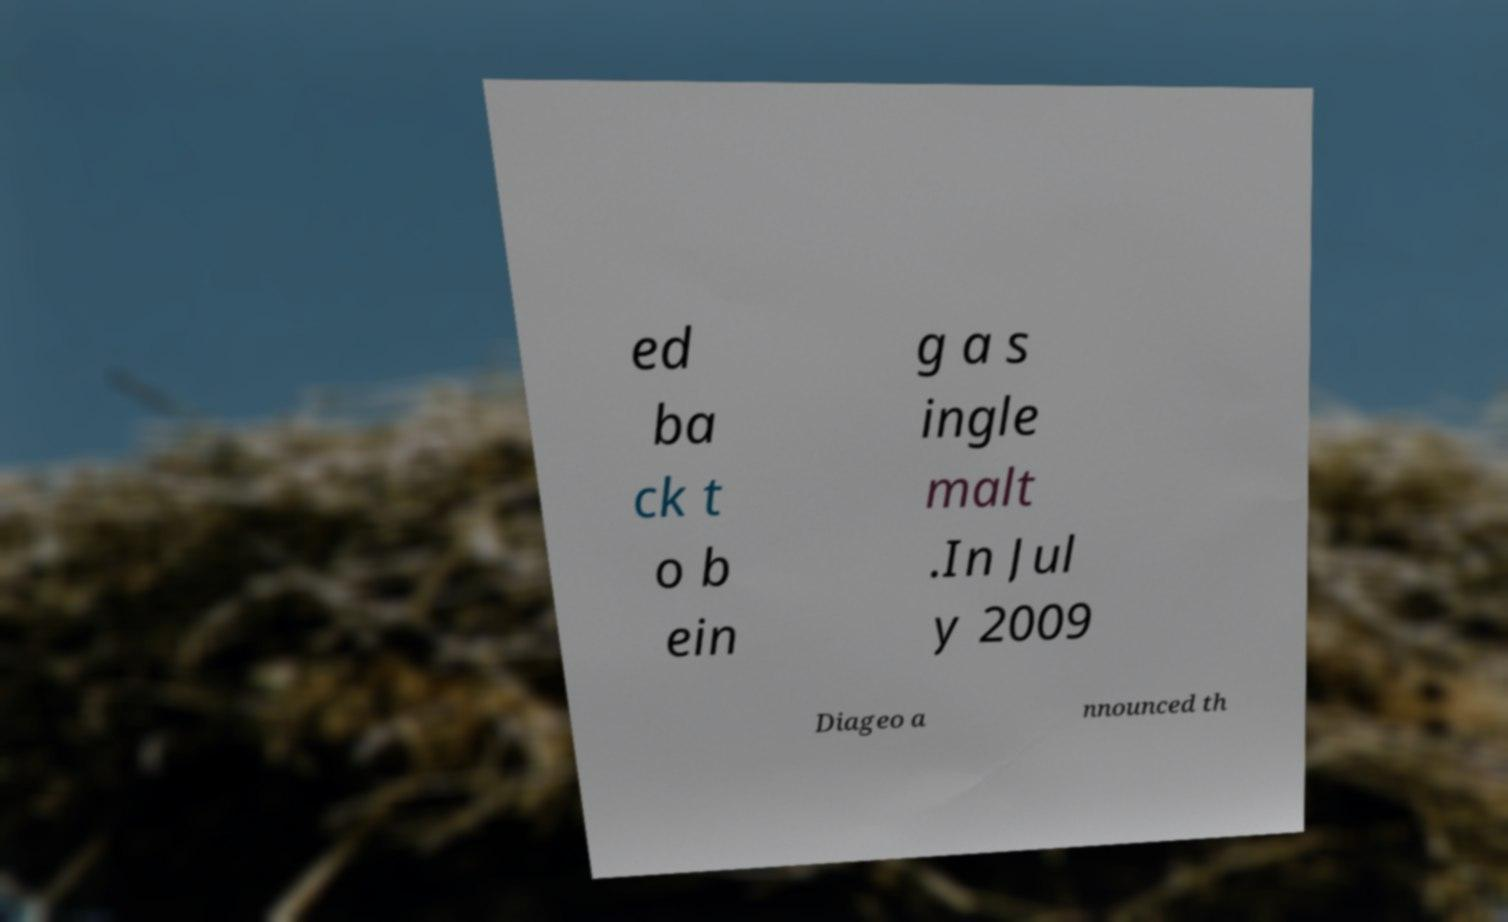Could you extract and type out the text from this image? ed ba ck t o b ein g a s ingle malt .In Jul y 2009 Diageo a nnounced th 